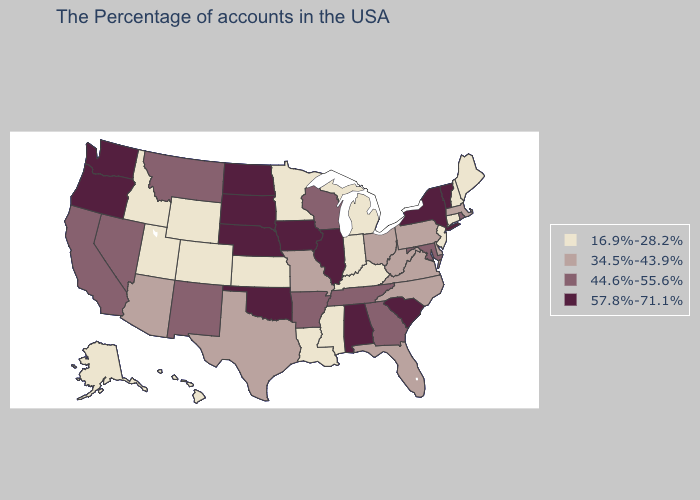Name the states that have a value in the range 57.8%-71.1%?
Be succinct. Vermont, New York, South Carolina, Alabama, Illinois, Iowa, Nebraska, Oklahoma, South Dakota, North Dakota, Washington, Oregon. Which states have the highest value in the USA?
Give a very brief answer. Vermont, New York, South Carolina, Alabama, Illinois, Iowa, Nebraska, Oklahoma, South Dakota, North Dakota, Washington, Oregon. Does Oklahoma have the highest value in the USA?
Write a very short answer. Yes. Does North Dakota have the lowest value in the MidWest?
Quick response, please. No. What is the lowest value in states that border Wyoming?
Answer briefly. 16.9%-28.2%. Name the states that have a value in the range 44.6%-55.6%?
Concise answer only. Rhode Island, Maryland, Georgia, Tennessee, Wisconsin, Arkansas, New Mexico, Montana, Nevada, California. Name the states that have a value in the range 44.6%-55.6%?
Short answer required. Rhode Island, Maryland, Georgia, Tennessee, Wisconsin, Arkansas, New Mexico, Montana, Nevada, California. Name the states that have a value in the range 57.8%-71.1%?
Be succinct. Vermont, New York, South Carolina, Alabama, Illinois, Iowa, Nebraska, Oklahoma, South Dakota, North Dakota, Washington, Oregon. Among the states that border North Carolina , which have the lowest value?
Answer briefly. Virginia. What is the lowest value in the USA?
Concise answer only. 16.9%-28.2%. Which states hav the highest value in the South?
Write a very short answer. South Carolina, Alabama, Oklahoma. Is the legend a continuous bar?
Quick response, please. No. What is the value of Minnesota?
Quick response, please. 16.9%-28.2%. Is the legend a continuous bar?
Answer briefly. No. Name the states that have a value in the range 57.8%-71.1%?
Concise answer only. Vermont, New York, South Carolina, Alabama, Illinois, Iowa, Nebraska, Oklahoma, South Dakota, North Dakota, Washington, Oregon. 